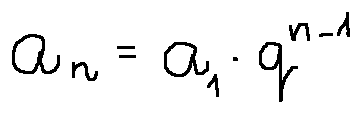Convert formula to latex. <formula><loc_0><loc_0><loc_500><loc_500>a _ { n } = a _ { 1 } \cdot q ^ { n - 1 }</formula> 